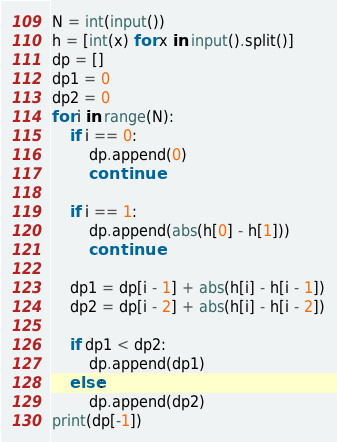<code> <loc_0><loc_0><loc_500><loc_500><_Python_>N = int(input())
h = [int(x) for x in input().split()]
dp = []
dp1 = 0
dp2 = 0
for i in range(N):
    if i == 0:
        dp.append(0)
        continue

    if i == 1:
        dp.append(abs(h[0] - h[1]))
        continue

    dp1 = dp[i - 1] + abs(h[i] - h[i - 1])
    dp2 = dp[i - 2] + abs(h[i] - h[i - 2])

    if dp1 < dp2:
        dp.append(dp1)
    else:
        dp.append(dp2)
print(dp[-1])
</code> 